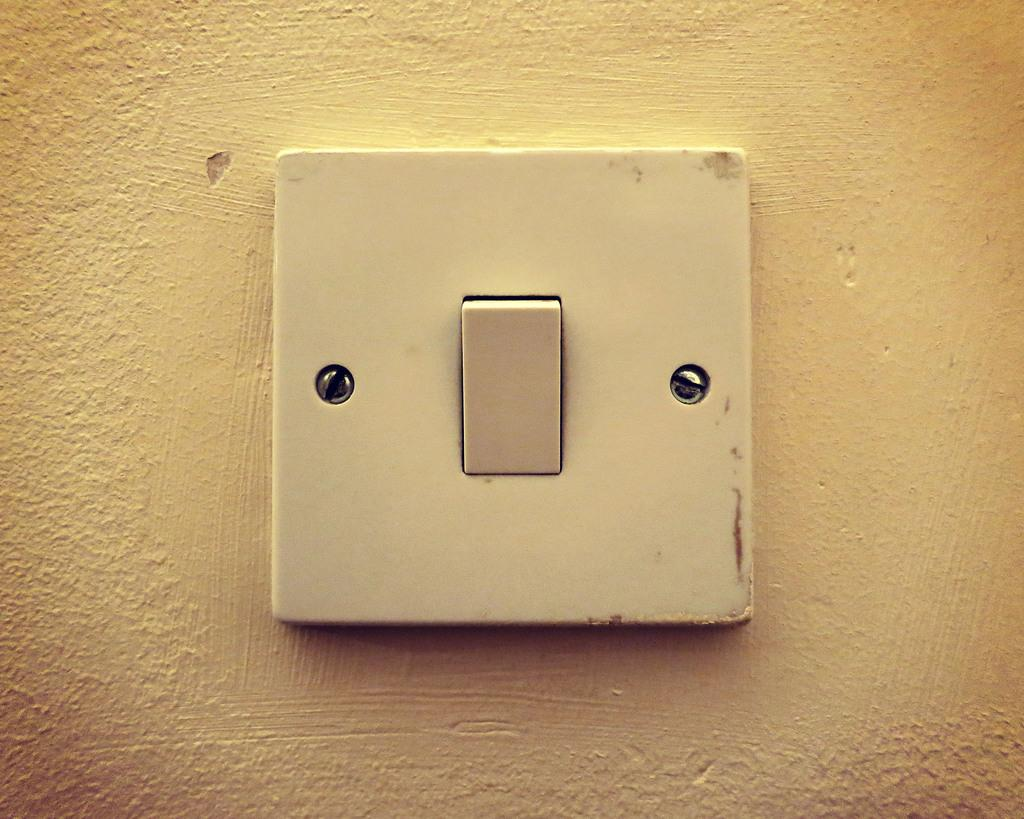What is the main subject of the image? The main subject of the image is a switchboard. Where is the switchboard located in the image? The switchboard is fixed to a wall. What type of toys can be seen playing in the scene in the image? There are no toys or scenes present in the image; it features a switchboard fixed to a wall. 